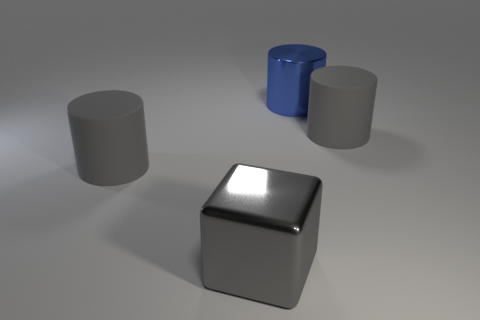Add 3 tiny green objects. How many objects exist? 7 Subtract all gray rubber cylinders. How many cylinders are left? 1 Subtract all brown spheres. How many gray cylinders are left? 2 Subtract all blue cylinders. How many cylinders are left? 2 Subtract all yellow cylinders. Subtract all blue balls. How many cylinders are left? 3 Subtract 2 gray cylinders. How many objects are left? 2 Subtract all cubes. How many objects are left? 3 Subtract all gray shiny cylinders. Subtract all metal cylinders. How many objects are left? 3 Add 2 gray matte cylinders. How many gray matte cylinders are left? 4 Add 4 large gray blocks. How many large gray blocks exist? 5 